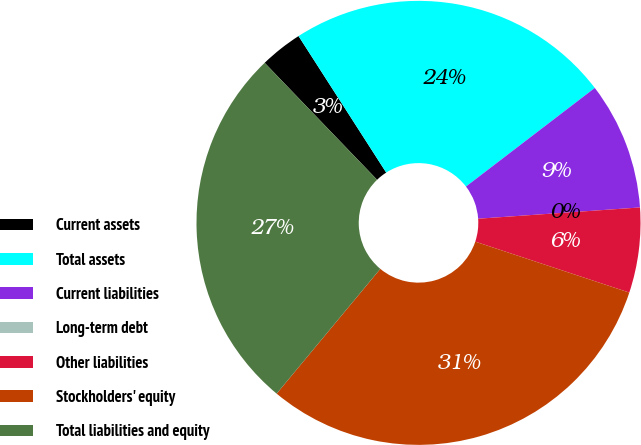Convert chart. <chart><loc_0><loc_0><loc_500><loc_500><pie_chart><fcel>Current assets<fcel>Total assets<fcel>Current liabilities<fcel>Long-term debt<fcel>Other liabilities<fcel>Stockholders' equity<fcel>Total liabilities and equity<nl><fcel>3.1%<fcel>23.69%<fcel>9.29%<fcel>0.0%<fcel>6.19%<fcel>30.95%<fcel>26.78%<nl></chart> 